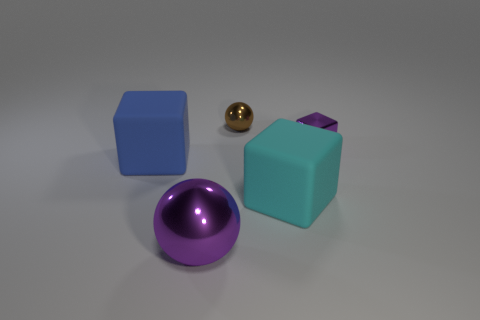What time of day does this lighting remind you of? The lighting in the image is soft and diffused, without harsh shadows, which resembles the natural light on an overcast day or possibly the ambient light in a studio setting with no natural daylight. 